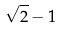Convert formula to latex. <formula><loc_0><loc_0><loc_500><loc_500>\sqrt { 2 } - 1</formula> 